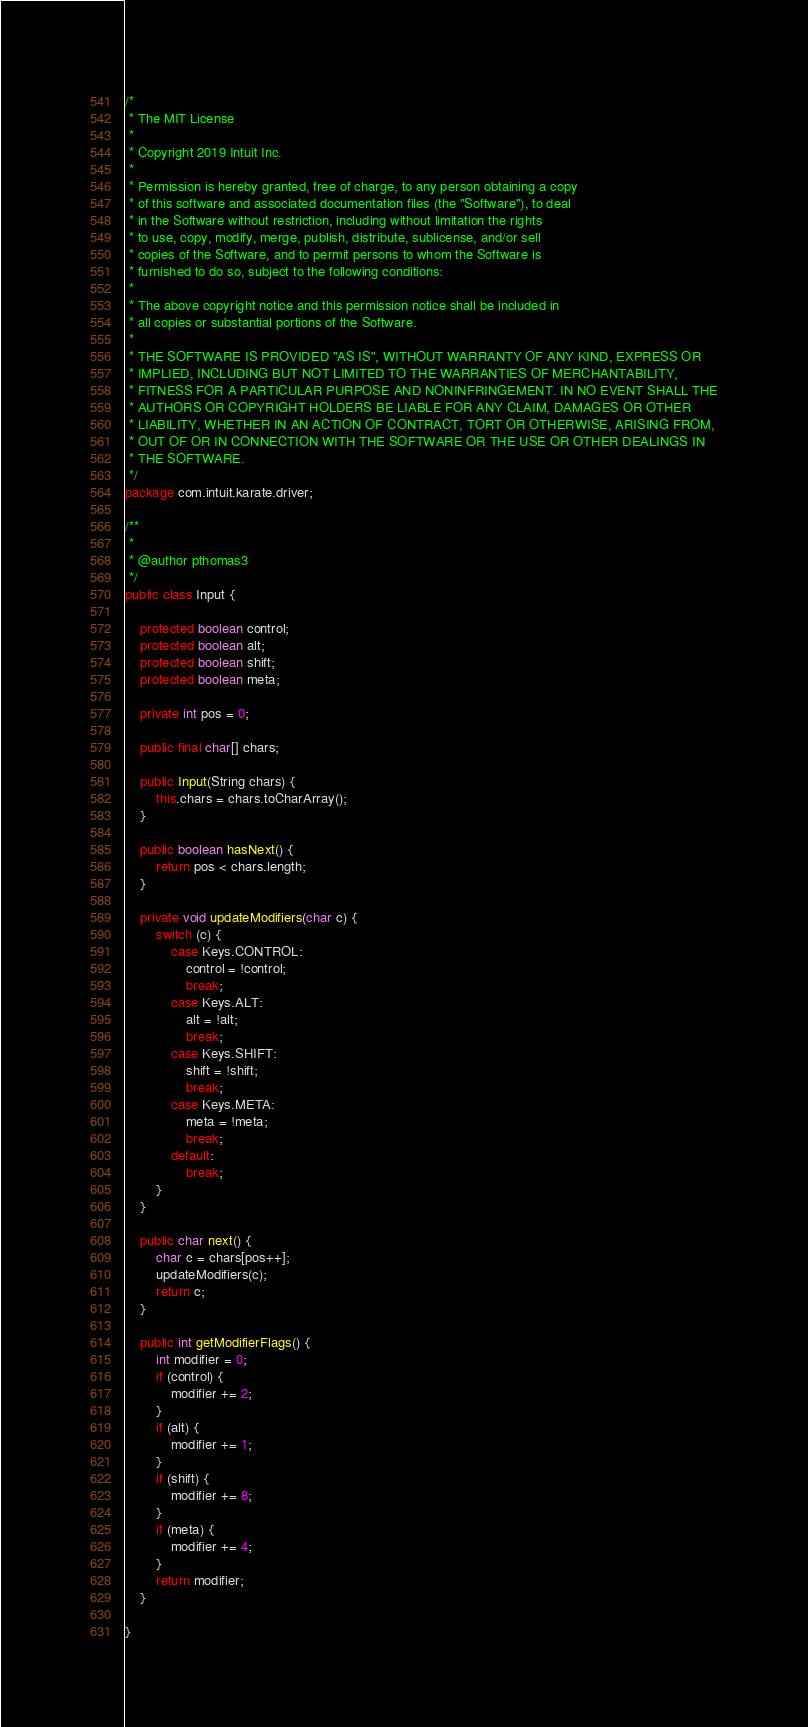<code> <loc_0><loc_0><loc_500><loc_500><_Java_>/*
 * The MIT License
 *
 * Copyright 2019 Intuit Inc.
 *
 * Permission is hereby granted, free of charge, to any person obtaining a copy
 * of this software and associated documentation files (the "Software"), to deal
 * in the Software without restriction, including without limitation the rights
 * to use, copy, modify, merge, publish, distribute, sublicense, and/or sell
 * copies of the Software, and to permit persons to whom the Software is
 * furnished to do so, subject to the following conditions:
 *
 * The above copyright notice and this permission notice shall be included in
 * all copies or substantial portions of the Software.
 *
 * THE SOFTWARE IS PROVIDED "AS IS", WITHOUT WARRANTY OF ANY KIND, EXPRESS OR
 * IMPLIED, INCLUDING BUT NOT LIMITED TO THE WARRANTIES OF MERCHANTABILITY,
 * FITNESS FOR A PARTICULAR PURPOSE AND NONINFRINGEMENT. IN NO EVENT SHALL THE
 * AUTHORS OR COPYRIGHT HOLDERS BE LIABLE FOR ANY CLAIM, DAMAGES OR OTHER
 * LIABILITY, WHETHER IN AN ACTION OF CONTRACT, TORT OR OTHERWISE, ARISING FROM,
 * OUT OF OR IN CONNECTION WITH THE SOFTWARE OR THE USE OR OTHER DEALINGS IN
 * THE SOFTWARE.
 */
package com.intuit.karate.driver;

/**
 *
 * @author pthomas3
 */
public class Input {

    protected boolean control;
    protected boolean alt;
    protected boolean shift;
    protected boolean meta;

    private int pos = 0;

    public final char[] chars;

    public Input(String chars) {
        this.chars = chars.toCharArray();
    }

    public boolean hasNext() {
        return pos < chars.length;
    }

    private void updateModifiers(char c) {
        switch (c) {
            case Keys.CONTROL:
                control = !control;
                break;
            case Keys.ALT:
                alt = !alt;
                break;
            case Keys.SHIFT:
                shift = !shift;
                break;
            case Keys.META:
                meta = !meta;
                break;
            default:
                break;
        }
    }

    public char next() {
        char c = chars[pos++];
        updateModifiers(c);
        return c;
    }

    public int getModifierFlags() {
        int modifier = 0;
        if (control) {
            modifier += 2;
        }
        if (alt) {
            modifier += 1;
        }
        if (shift) {
            modifier += 8;
        }
        if (meta) {
            modifier += 4;
        }
        return modifier;
    }

}
</code> 